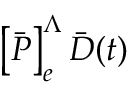<formula> <loc_0><loc_0><loc_500><loc_500>\left [ \bar { P } \right ] _ { e } ^ { \Lambda } \bar { D } ( t )</formula> 